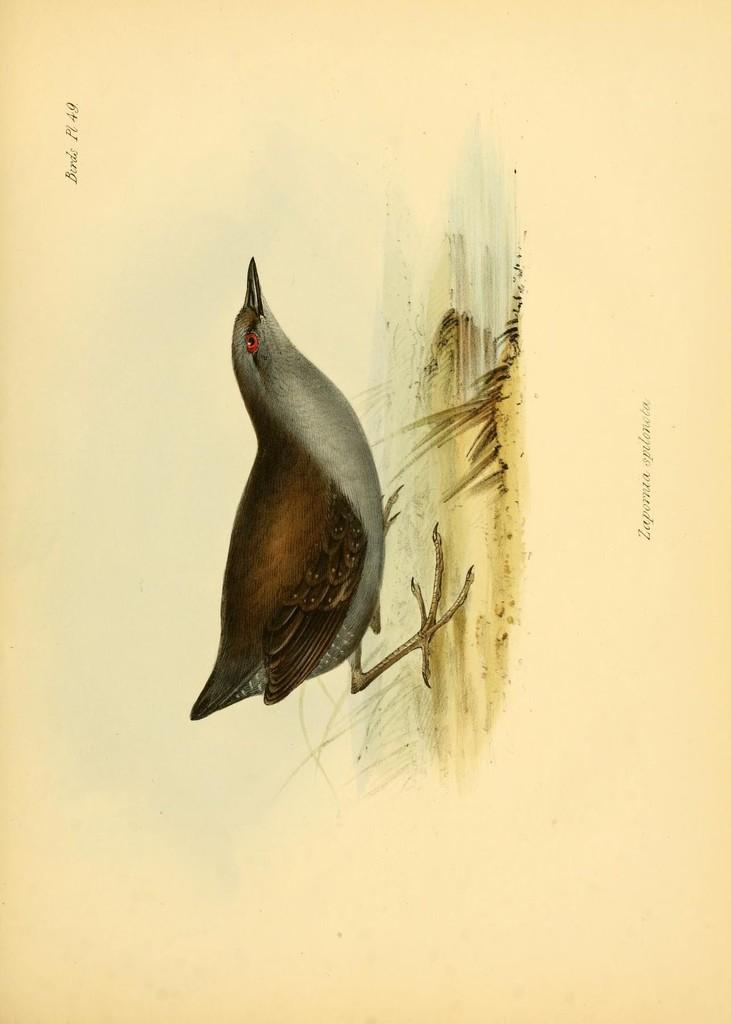What is the main subject of the painting in the image? The painting depicts a bird. Are there any other elements in the painting besides the bird? Yes, the painting also includes some grass. What degree does the bird have in the painting? The painting does not depict the bird's degree, as it is not a living being with educational qualifications. 